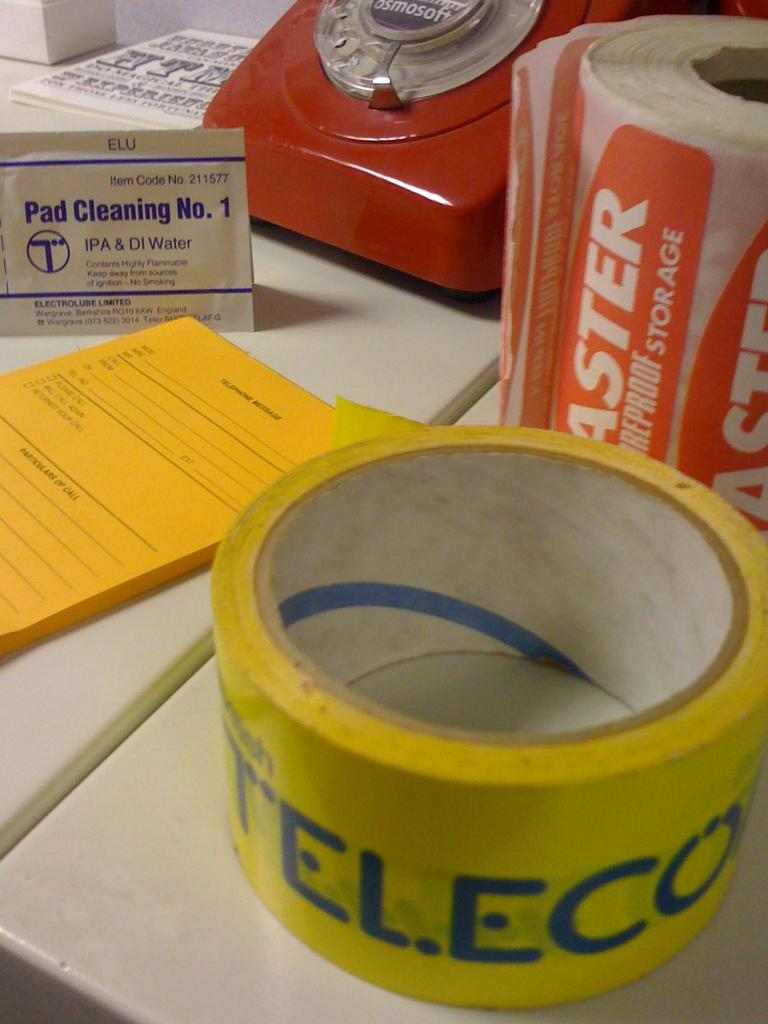What type of communication device is present in the image? There is a telephone in the image. What is another object that can be seen in the image? There is a book in the image. Can you identify any other objects with a specific function in the image? Yes, there is a tap in the image. Are there any other objects with text in the image? Yes, there are other objects with text in the image. On what surface are all these objects placed? All these objects are placed on a surface. How many balloons are floating in the image? There are no balloons present in the image. What season is depicted in the image? The provided facts do not mention any seasonal elements, so it cannot be determined from the image. 